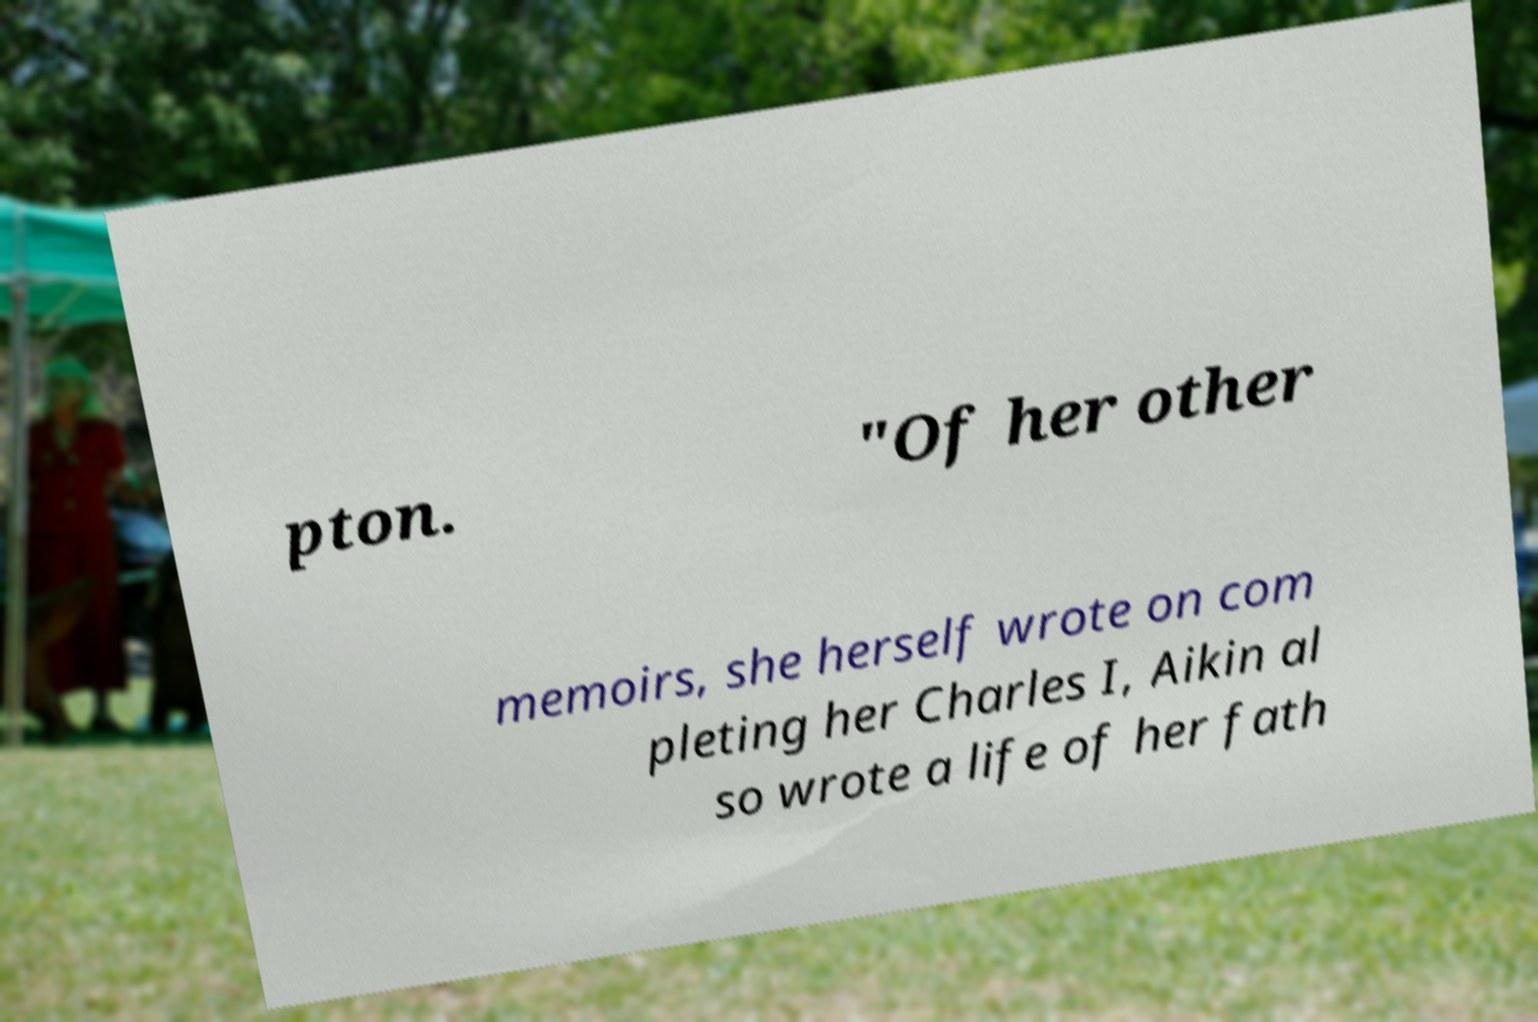Could you assist in decoding the text presented in this image and type it out clearly? pton. "Of her other memoirs, she herself wrote on com pleting her Charles I, Aikin al so wrote a life of her fath 